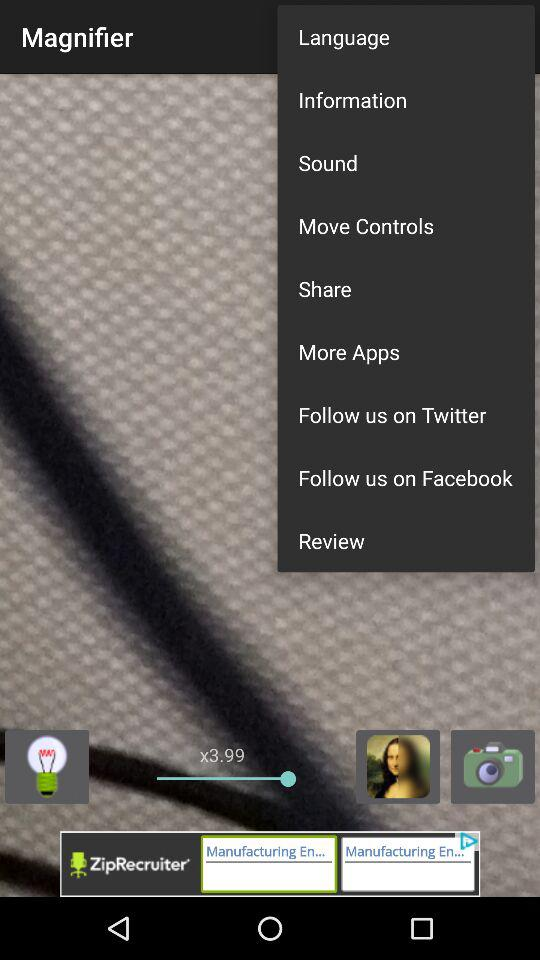What does the magnifier point shows on the screen?
When the provided information is insufficient, respond with <no answer>. <no answer> 